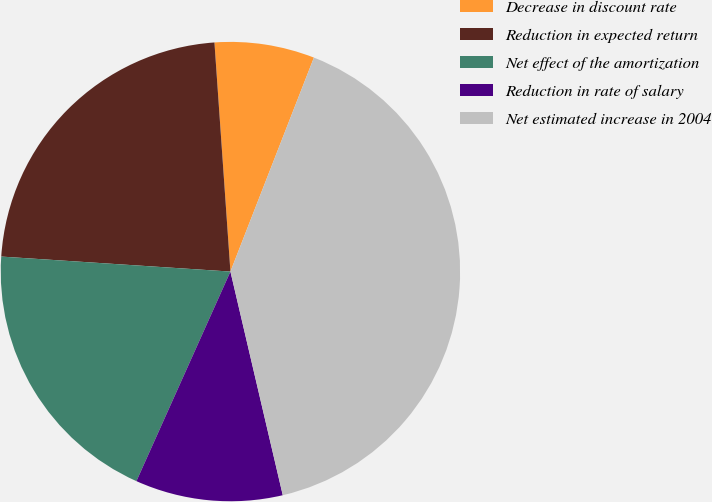Convert chart. <chart><loc_0><loc_0><loc_500><loc_500><pie_chart><fcel>Decrease in discount rate<fcel>Reduction in expected return<fcel>Net effect of the amortization<fcel>Reduction in rate of salary<fcel>Net estimated increase in 2004<nl><fcel>7.03%<fcel>22.85%<fcel>19.33%<fcel>10.37%<fcel>40.42%<nl></chart> 